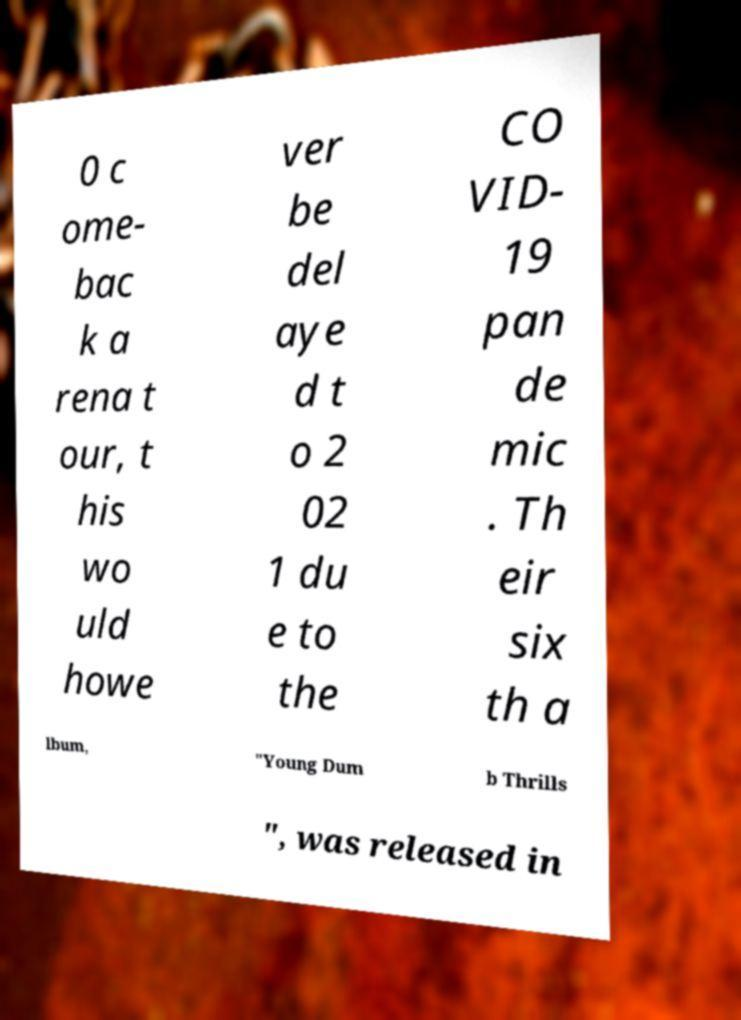I need the written content from this picture converted into text. Can you do that? 0 c ome- bac k a rena t our, t his wo uld howe ver be del aye d t o 2 02 1 du e to the CO VID- 19 pan de mic . Th eir six th a lbum, "Young Dum b Thrills ", was released in 